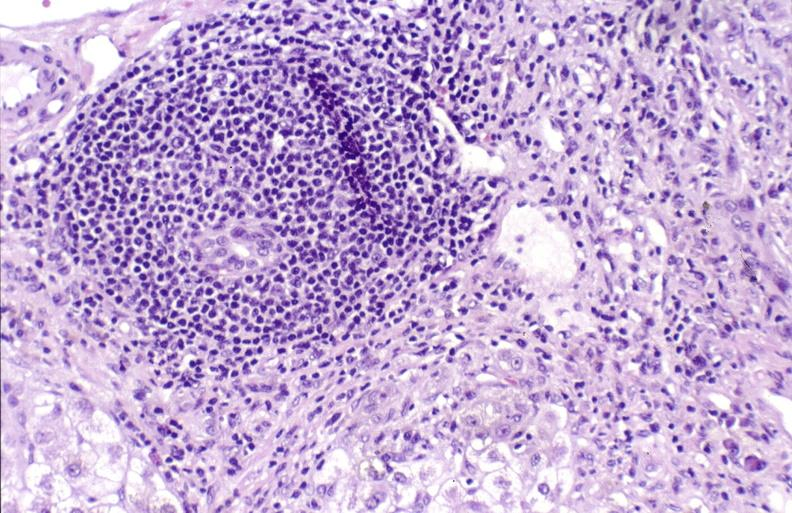what is present?
Answer the question using a single word or phrase. Liver 